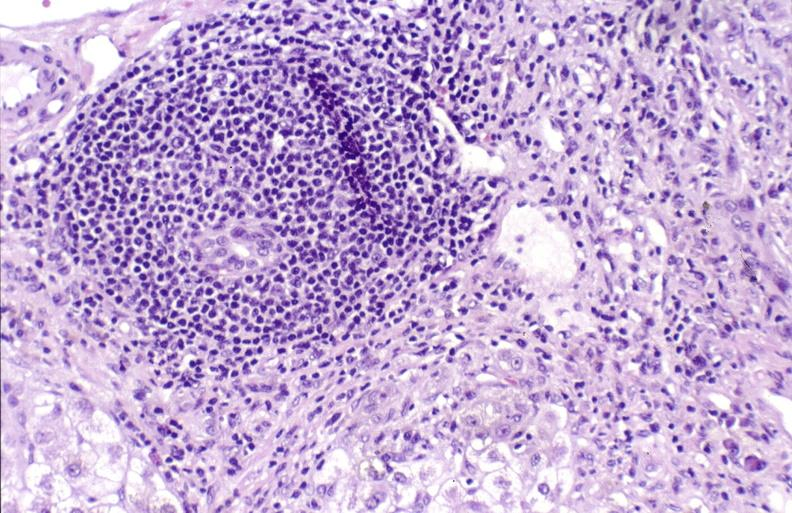what is present?
Answer the question using a single word or phrase. Liver 